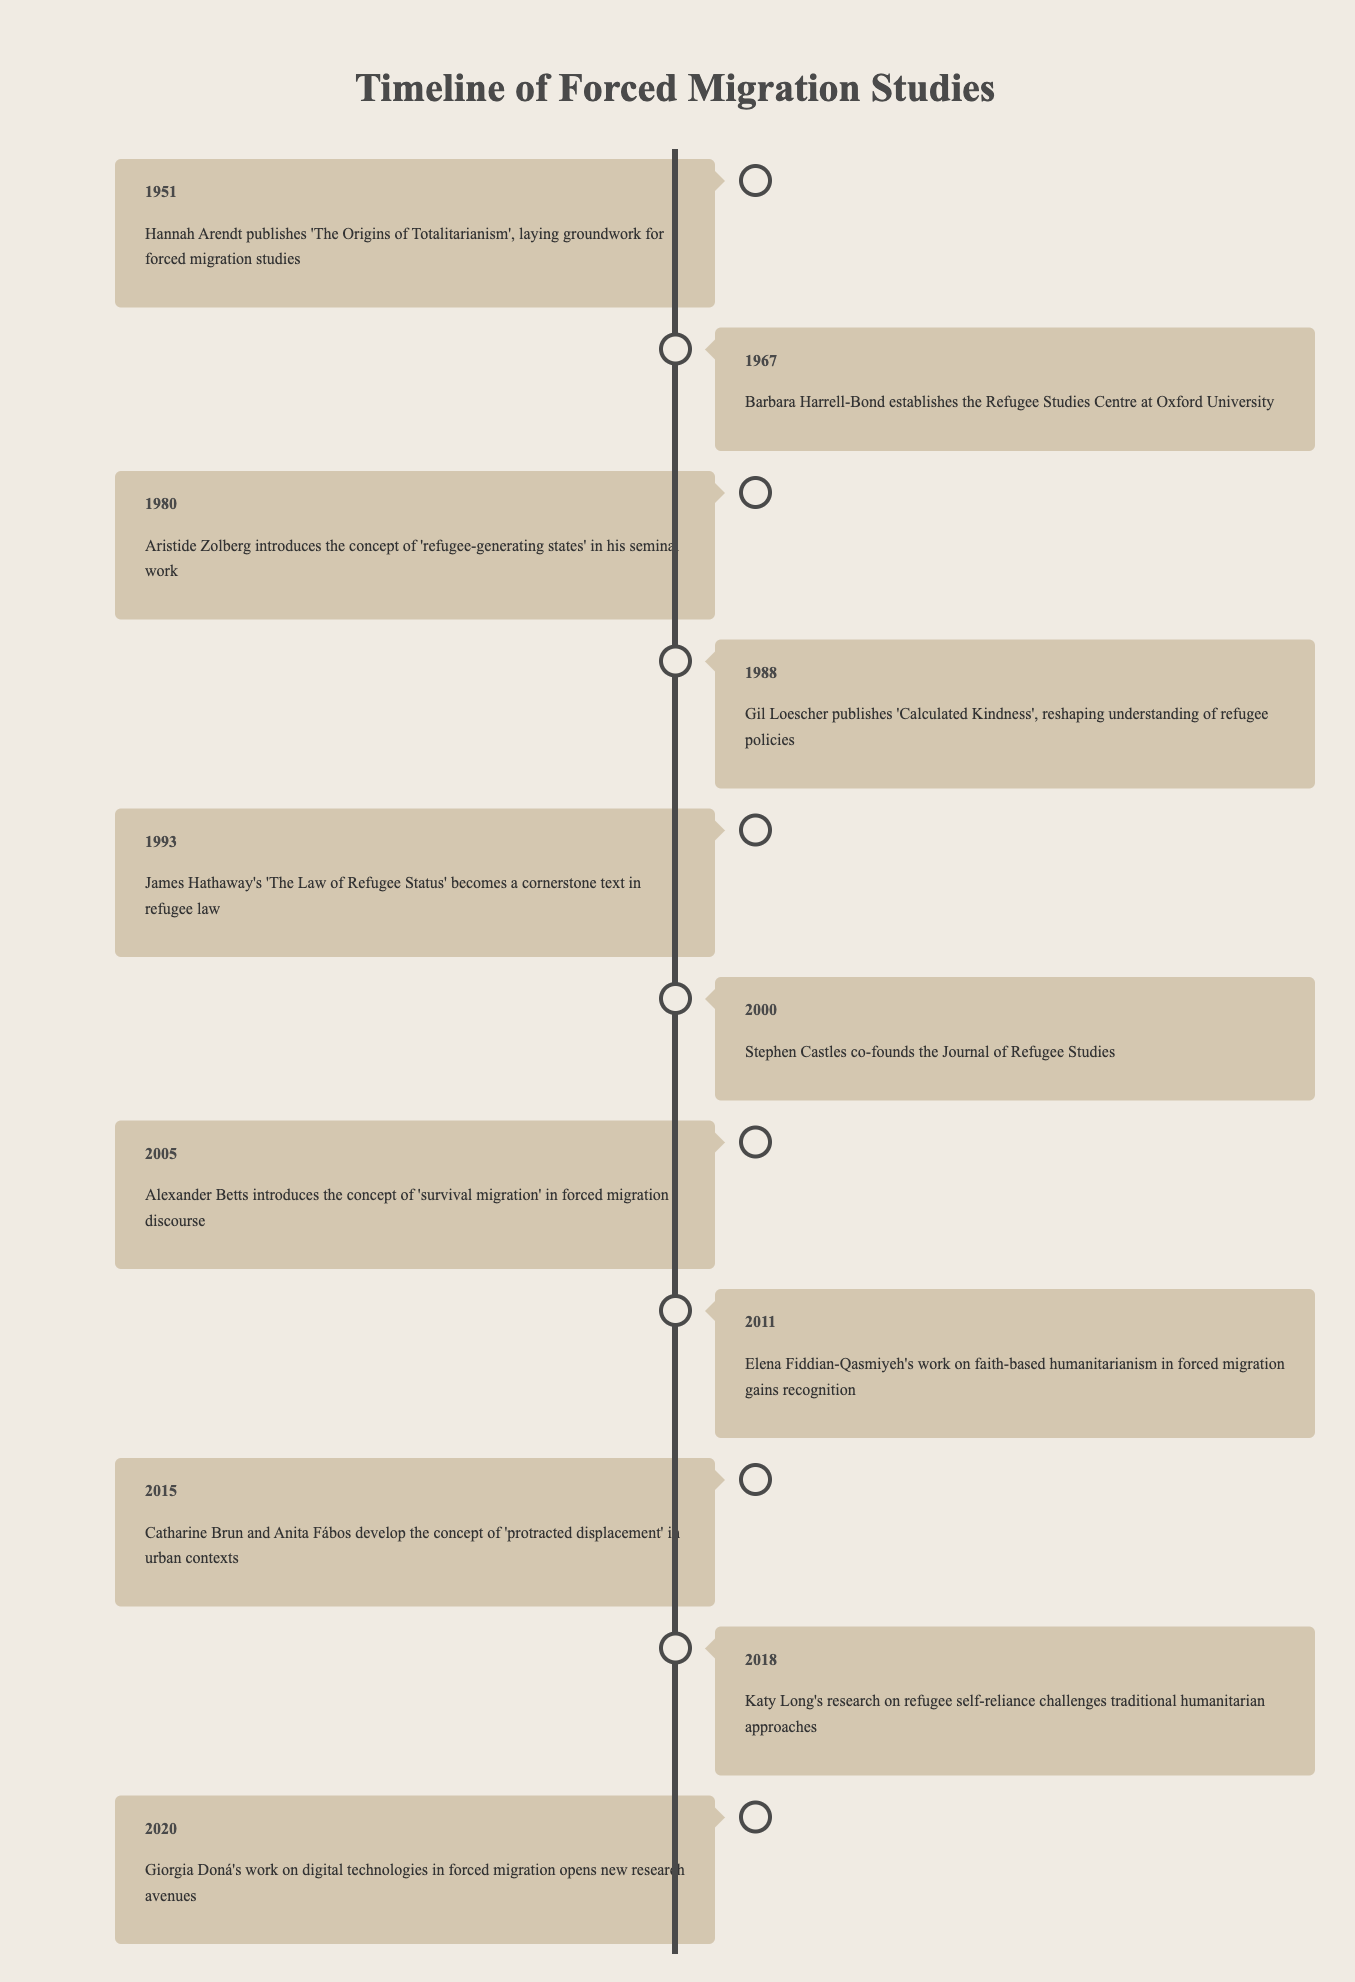What significant publication did Hannah Arendt release in 1951? The table states that in 1951, Hannah Arendt published 'The Origins of Totalitarianism', which is noted as laying the groundwork for forced migration studies.
Answer: 'The Origins of Totalitarianism' Who established the Refugee Studies Centre at Oxford University? According to the table, Barbara Harrell-Bond is identified as the person who established the Refugee Studies Centre at Oxford University in 1967.
Answer: Barbara Harrell-Bond In what year did Stephen Castles co-found the Journal of Refugee Studies? The table indicates that Stephen Castles co-founded the Journal of Refugee Studies in the year 2000, as listed in the corresponding entry.
Answer: 2000 Which two researchers developed the concept of 'protracted displacement' and in what year? The table lists that Catharine Brun and Anita Fábos developed the concept of 'protracted displacement' in urban contexts in the year 2015.
Answer: Catharine Brun and Anita Fábos in 2015 True or False: Gil Loescher published 'Calculated Kindness' before 1990. By examining the timeline, it can be seen that Gil Loescher published 'Calculated Kindness' in 1988, which is indeed before 1990, thus making the statement true.
Answer: True What is the time span between the establishment of the Refugee Studies Centre and the introduction of the concept of 'survival migration'? The Refugee Studies Centre was established in 1967 and the concept of 'survival migration' was introduced in 2005. To find the time span, subtract 1967 from 2005, which gives 38 years.
Answer: 38 years How many scholars made significant contributions to forced migration studies between 2000 and 2020? Looking at the timeline, from 2000 to 2020, there are four scholars mentioned: Stephen Castles (2000), Alexander Betts (2005), Elena Fiddian-Qasmiyeh (2011), and Giorgia Doná (2020). Thus, the count is 4 scholars.
Answer: 4 scholars Identify the last scholar mentioned in the timeline and their contribution. The last entry in the timeline is for Giorgia Doná in 2020, whose work on digital technologies in forced migration is noted to have opened new research avenues.
Answer: Giorgia Doná - digital technologies in forced migration What are the key themes or concepts introduced by the scholars listed between 1980 and 2015? Analyzing the timeline, the key themes are 'refugee-generating states' by Aristide Zolberg (1980), 'Calculated Kindness' by Gil Loescher (1988), 'The Law of Refugee Status' by James Hathaway (1993), and 'protracted displacement' developed by Catharine Brun and Anita Fábos (2015), indicating a focus on policies, legal frameworks, and urban contexts in displacement scenarios.
Answer: Refugee-generating states, policies, legal frameworks, protracted displacement 